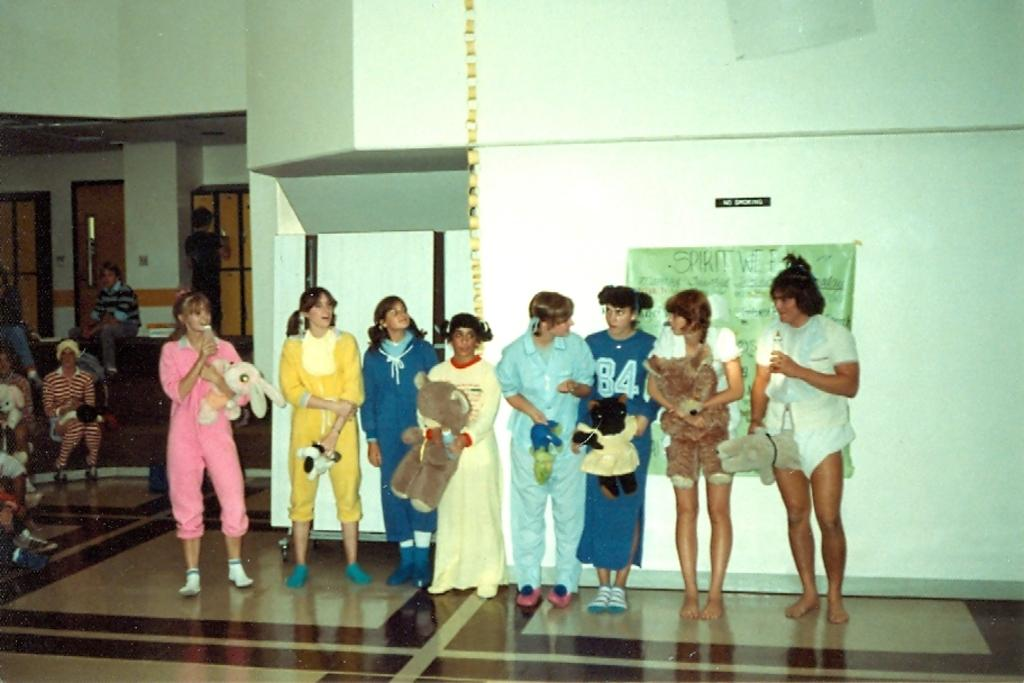What is the main subject of the image? The main subject of the image is a group of girls. What are the girls holding in their hands? The girls are holding dolls in their hands. Can you describe the background of the image? There is a banner on the wall in the background. What type of sofa can be seen in the image? There is no sofa present in the image. 